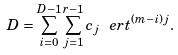Convert formula to latex. <formula><loc_0><loc_0><loc_500><loc_500>D = \sum _ { i = 0 } ^ { D - 1 } \sum _ { j = 1 } ^ { r - 1 } c _ { j } \ e r t ^ { ( m - i ) j } .</formula> 